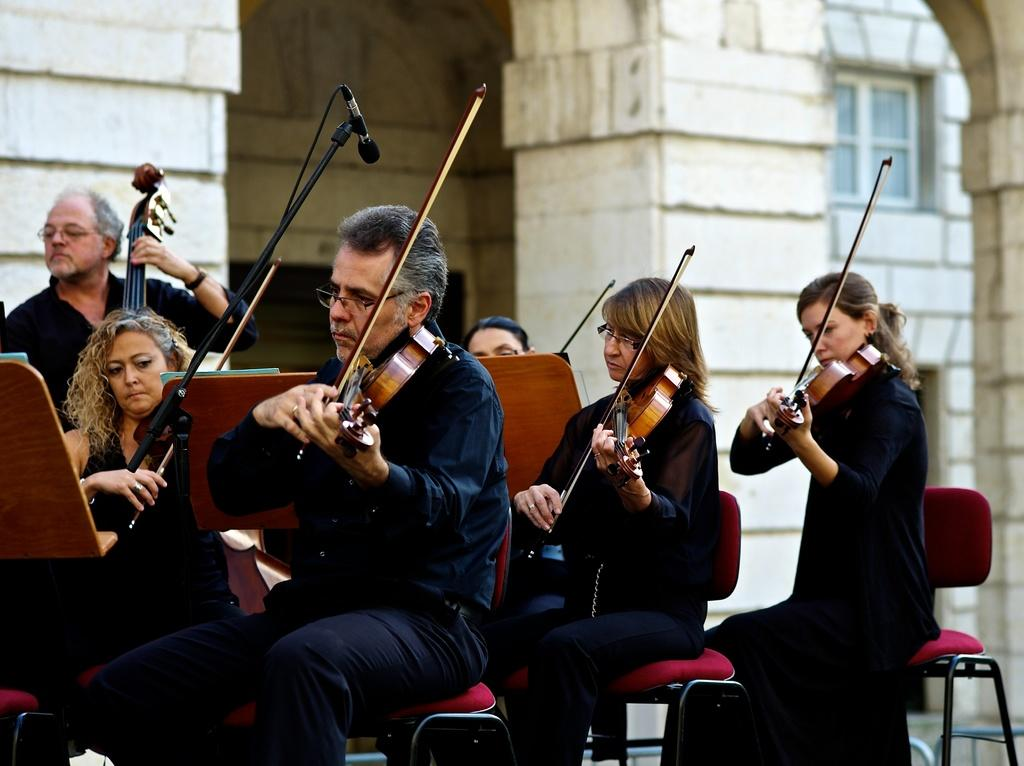How many people are in the image? There is a group of persons in the image. What are the persons doing in the image? The persons are sitting on chairs and holding a violin. What can be seen in the background of the image? There is a building in the background of the image. What type of nail is being used to play the violin in the image? There is no nail being used to play the violin in the image; the persons are holding the violin with their hands. 